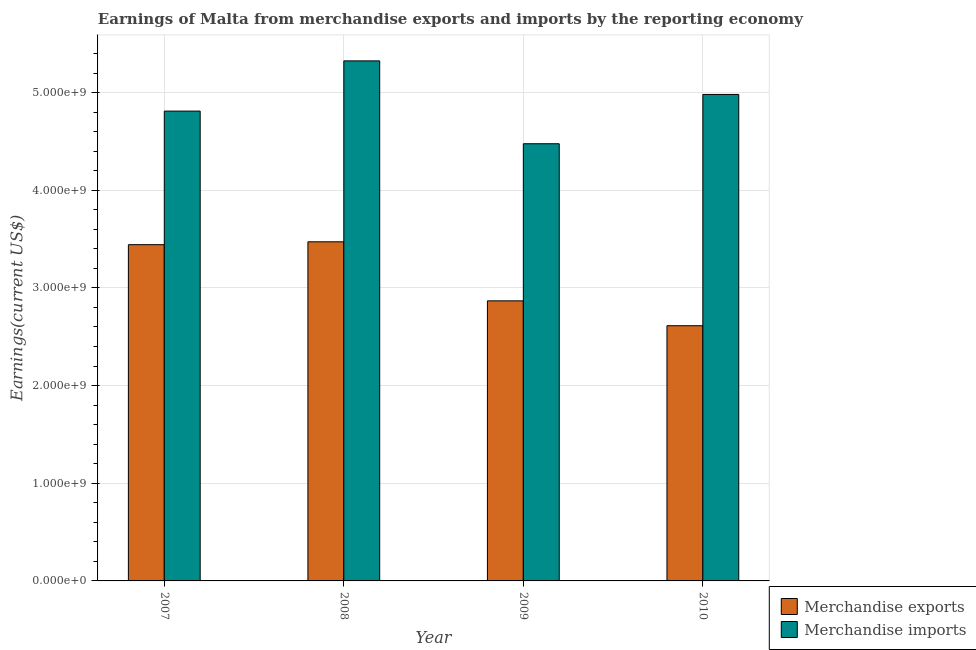How many groups of bars are there?
Keep it short and to the point. 4. Are the number of bars per tick equal to the number of legend labels?
Ensure brevity in your answer.  Yes. How many bars are there on the 4th tick from the right?
Give a very brief answer. 2. What is the earnings from merchandise imports in 2010?
Your response must be concise. 4.98e+09. Across all years, what is the maximum earnings from merchandise imports?
Keep it short and to the point. 5.32e+09. Across all years, what is the minimum earnings from merchandise exports?
Your response must be concise. 2.61e+09. In which year was the earnings from merchandise imports maximum?
Your response must be concise. 2008. What is the total earnings from merchandise imports in the graph?
Give a very brief answer. 1.96e+1. What is the difference between the earnings from merchandise imports in 2008 and that in 2009?
Keep it short and to the point. 8.48e+08. What is the difference between the earnings from merchandise exports in 2008 and the earnings from merchandise imports in 2010?
Your answer should be compact. 8.59e+08. What is the average earnings from merchandise imports per year?
Make the answer very short. 4.90e+09. What is the ratio of the earnings from merchandise imports in 2008 to that in 2009?
Make the answer very short. 1.19. Is the difference between the earnings from merchandise imports in 2008 and 2010 greater than the difference between the earnings from merchandise exports in 2008 and 2010?
Ensure brevity in your answer.  No. What is the difference between the highest and the second highest earnings from merchandise imports?
Give a very brief answer. 3.44e+08. What is the difference between the highest and the lowest earnings from merchandise exports?
Your response must be concise. 8.59e+08. In how many years, is the earnings from merchandise imports greater than the average earnings from merchandise imports taken over all years?
Your answer should be very brief. 2. What does the 1st bar from the left in 2009 represents?
Your answer should be very brief. Merchandise exports. What does the 2nd bar from the right in 2009 represents?
Keep it short and to the point. Merchandise exports. Are all the bars in the graph horizontal?
Provide a succinct answer. No. What is the difference between two consecutive major ticks on the Y-axis?
Make the answer very short. 1.00e+09. Are the values on the major ticks of Y-axis written in scientific E-notation?
Your answer should be compact. Yes. Does the graph contain any zero values?
Give a very brief answer. No. Where does the legend appear in the graph?
Provide a succinct answer. Bottom right. How are the legend labels stacked?
Your response must be concise. Vertical. What is the title of the graph?
Offer a terse response. Earnings of Malta from merchandise exports and imports by the reporting economy. Does "National Visitors" appear as one of the legend labels in the graph?
Ensure brevity in your answer.  No. What is the label or title of the X-axis?
Your response must be concise. Year. What is the label or title of the Y-axis?
Provide a succinct answer. Earnings(current US$). What is the Earnings(current US$) in Merchandise exports in 2007?
Give a very brief answer. 3.44e+09. What is the Earnings(current US$) in Merchandise imports in 2007?
Keep it short and to the point. 4.81e+09. What is the Earnings(current US$) in Merchandise exports in 2008?
Ensure brevity in your answer.  3.47e+09. What is the Earnings(current US$) in Merchandise imports in 2008?
Your response must be concise. 5.32e+09. What is the Earnings(current US$) of Merchandise exports in 2009?
Keep it short and to the point. 2.87e+09. What is the Earnings(current US$) of Merchandise imports in 2009?
Keep it short and to the point. 4.48e+09. What is the Earnings(current US$) of Merchandise exports in 2010?
Make the answer very short. 2.61e+09. What is the Earnings(current US$) in Merchandise imports in 2010?
Offer a very short reply. 4.98e+09. Across all years, what is the maximum Earnings(current US$) of Merchandise exports?
Provide a succinct answer. 3.47e+09. Across all years, what is the maximum Earnings(current US$) of Merchandise imports?
Your answer should be compact. 5.32e+09. Across all years, what is the minimum Earnings(current US$) in Merchandise exports?
Your answer should be compact. 2.61e+09. Across all years, what is the minimum Earnings(current US$) of Merchandise imports?
Offer a terse response. 4.48e+09. What is the total Earnings(current US$) of Merchandise exports in the graph?
Your answer should be very brief. 1.24e+1. What is the total Earnings(current US$) in Merchandise imports in the graph?
Make the answer very short. 1.96e+1. What is the difference between the Earnings(current US$) in Merchandise exports in 2007 and that in 2008?
Keep it short and to the point. -2.95e+07. What is the difference between the Earnings(current US$) of Merchandise imports in 2007 and that in 2008?
Provide a succinct answer. -5.14e+08. What is the difference between the Earnings(current US$) of Merchandise exports in 2007 and that in 2009?
Your answer should be very brief. 5.75e+08. What is the difference between the Earnings(current US$) in Merchandise imports in 2007 and that in 2009?
Your answer should be very brief. 3.34e+08. What is the difference between the Earnings(current US$) of Merchandise exports in 2007 and that in 2010?
Offer a very short reply. 8.30e+08. What is the difference between the Earnings(current US$) of Merchandise imports in 2007 and that in 2010?
Make the answer very short. -1.71e+08. What is the difference between the Earnings(current US$) of Merchandise exports in 2008 and that in 2009?
Provide a short and direct response. 6.05e+08. What is the difference between the Earnings(current US$) of Merchandise imports in 2008 and that in 2009?
Give a very brief answer. 8.48e+08. What is the difference between the Earnings(current US$) in Merchandise exports in 2008 and that in 2010?
Ensure brevity in your answer.  8.59e+08. What is the difference between the Earnings(current US$) in Merchandise imports in 2008 and that in 2010?
Offer a very short reply. 3.44e+08. What is the difference between the Earnings(current US$) of Merchandise exports in 2009 and that in 2010?
Your answer should be compact. 2.55e+08. What is the difference between the Earnings(current US$) in Merchandise imports in 2009 and that in 2010?
Provide a short and direct response. -5.05e+08. What is the difference between the Earnings(current US$) in Merchandise exports in 2007 and the Earnings(current US$) in Merchandise imports in 2008?
Provide a short and direct response. -1.88e+09. What is the difference between the Earnings(current US$) in Merchandise exports in 2007 and the Earnings(current US$) in Merchandise imports in 2009?
Your response must be concise. -1.03e+09. What is the difference between the Earnings(current US$) of Merchandise exports in 2007 and the Earnings(current US$) of Merchandise imports in 2010?
Your answer should be very brief. -1.54e+09. What is the difference between the Earnings(current US$) in Merchandise exports in 2008 and the Earnings(current US$) in Merchandise imports in 2009?
Offer a very short reply. -1.00e+09. What is the difference between the Earnings(current US$) of Merchandise exports in 2008 and the Earnings(current US$) of Merchandise imports in 2010?
Keep it short and to the point. -1.51e+09. What is the difference between the Earnings(current US$) of Merchandise exports in 2009 and the Earnings(current US$) of Merchandise imports in 2010?
Offer a very short reply. -2.11e+09. What is the average Earnings(current US$) in Merchandise exports per year?
Your response must be concise. 3.10e+09. What is the average Earnings(current US$) in Merchandise imports per year?
Keep it short and to the point. 4.90e+09. In the year 2007, what is the difference between the Earnings(current US$) in Merchandise exports and Earnings(current US$) in Merchandise imports?
Offer a very short reply. -1.37e+09. In the year 2008, what is the difference between the Earnings(current US$) in Merchandise exports and Earnings(current US$) in Merchandise imports?
Offer a very short reply. -1.85e+09. In the year 2009, what is the difference between the Earnings(current US$) in Merchandise exports and Earnings(current US$) in Merchandise imports?
Offer a very short reply. -1.61e+09. In the year 2010, what is the difference between the Earnings(current US$) in Merchandise exports and Earnings(current US$) in Merchandise imports?
Your answer should be compact. -2.37e+09. What is the ratio of the Earnings(current US$) in Merchandise imports in 2007 to that in 2008?
Your response must be concise. 0.9. What is the ratio of the Earnings(current US$) of Merchandise exports in 2007 to that in 2009?
Your answer should be compact. 1.2. What is the ratio of the Earnings(current US$) in Merchandise imports in 2007 to that in 2009?
Ensure brevity in your answer.  1.07. What is the ratio of the Earnings(current US$) in Merchandise exports in 2007 to that in 2010?
Your answer should be very brief. 1.32. What is the ratio of the Earnings(current US$) in Merchandise imports in 2007 to that in 2010?
Offer a very short reply. 0.97. What is the ratio of the Earnings(current US$) in Merchandise exports in 2008 to that in 2009?
Offer a terse response. 1.21. What is the ratio of the Earnings(current US$) in Merchandise imports in 2008 to that in 2009?
Your response must be concise. 1.19. What is the ratio of the Earnings(current US$) in Merchandise exports in 2008 to that in 2010?
Your answer should be very brief. 1.33. What is the ratio of the Earnings(current US$) of Merchandise imports in 2008 to that in 2010?
Give a very brief answer. 1.07. What is the ratio of the Earnings(current US$) of Merchandise exports in 2009 to that in 2010?
Make the answer very short. 1.1. What is the ratio of the Earnings(current US$) in Merchandise imports in 2009 to that in 2010?
Ensure brevity in your answer.  0.9. What is the difference between the highest and the second highest Earnings(current US$) of Merchandise exports?
Make the answer very short. 2.95e+07. What is the difference between the highest and the second highest Earnings(current US$) in Merchandise imports?
Your answer should be very brief. 3.44e+08. What is the difference between the highest and the lowest Earnings(current US$) in Merchandise exports?
Provide a short and direct response. 8.59e+08. What is the difference between the highest and the lowest Earnings(current US$) of Merchandise imports?
Provide a succinct answer. 8.48e+08. 